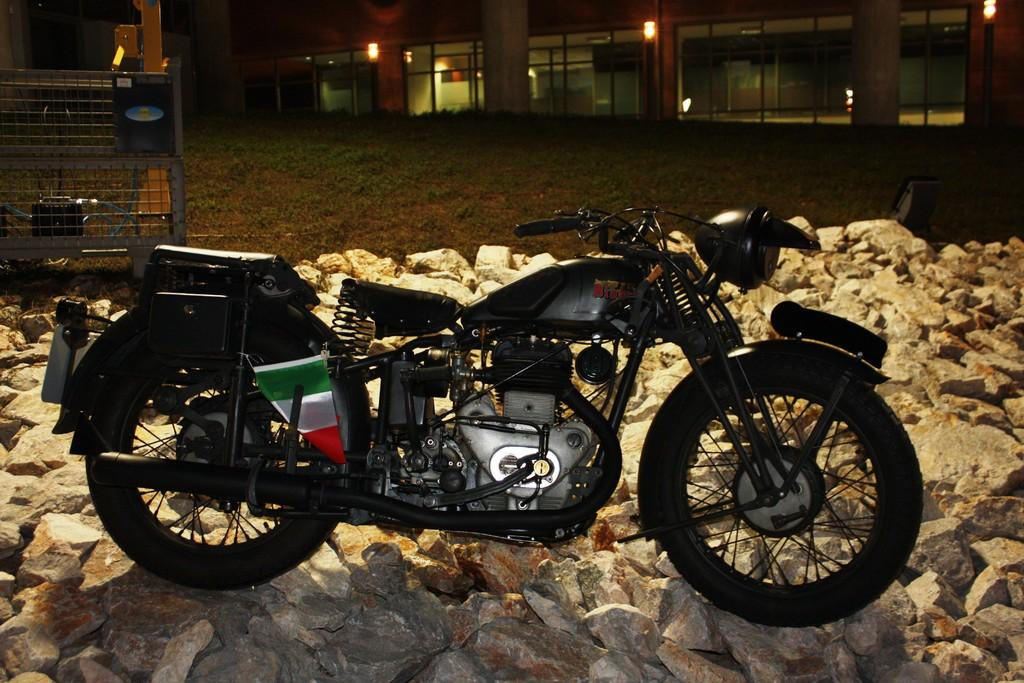What is the main subject in the center of the image? There is a bike in the center of the image. What else can be seen in the center of the image? There are stones in the center of the image. What can be seen in the background of the image? There is a building, grass, lights, and a few other objects in the background of the image. How many women are present in the image? There is no mention of women in the image. 